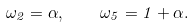<formula> <loc_0><loc_0><loc_500><loc_500>\omega _ { 2 } = \alpha , \quad \omega _ { 5 } = 1 + \alpha .</formula> 